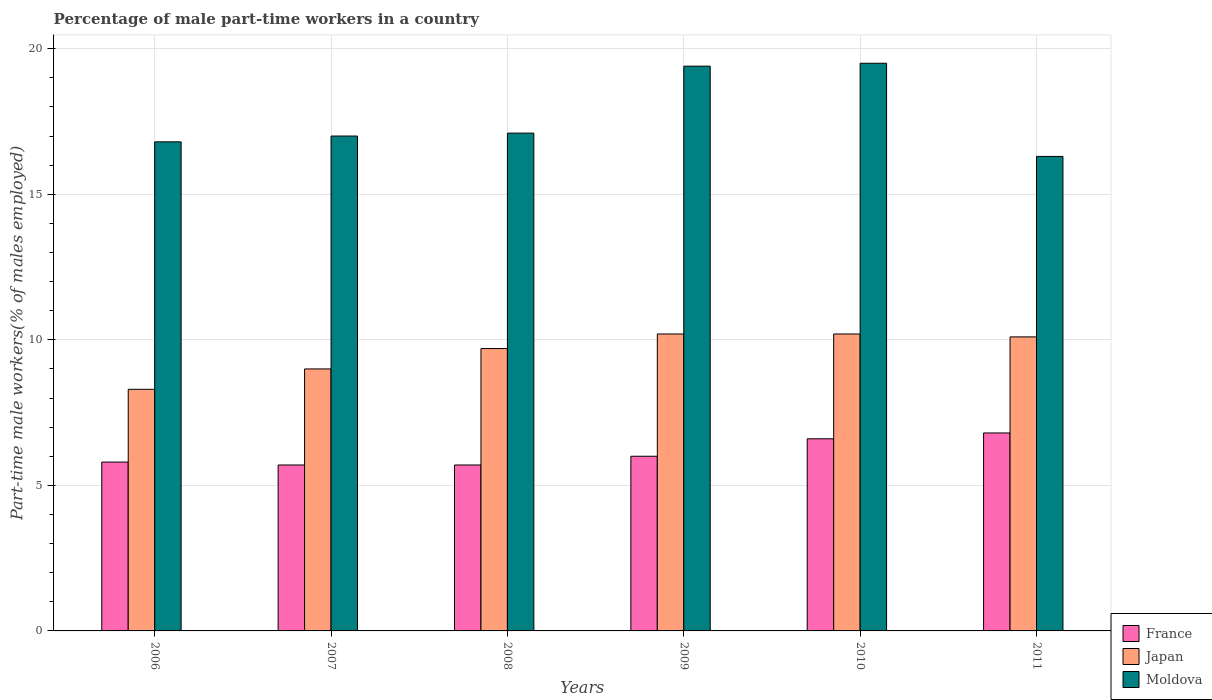How many groups of bars are there?
Make the answer very short. 6. Are the number of bars per tick equal to the number of legend labels?
Your answer should be very brief. Yes. How many bars are there on the 4th tick from the right?
Make the answer very short. 3. In how many cases, is the number of bars for a given year not equal to the number of legend labels?
Your response must be concise. 0. What is the percentage of male part-time workers in Moldova in 2007?
Your answer should be compact. 17. Across all years, what is the maximum percentage of male part-time workers in Moldova?
Your answer should be compact. 19.5. Across all years, what is the minimum percentage of male part-time workers in France?
Your answer should be compact. 5.7. What is the total percentage of male part-time workers in Japan in the graph?
Provide a succinct answer. 57.5. What is the difference between the percentage of male part-time workers in Japan in 2007 and that in 2009?
Offer a very short reply. -1.2. What is the difference between the percentage of male part-time workers in Japan in 2008 and the percentage of male part-time workers in France in 2010?
Offer a terse response. 3.1. What is the average percentage of male part-time workers in France per year?
Keep it short and to the point. 6.1. In the year 2006, what is the difference between the percentage of male part-time workers in Japan and percentage of male part-time workers in Moldova?
Ensure brevity in your answer.  -8.5. In how many years, is the percentage of male part-time workers in France greater than 14 %?
Your answer should be compact. 0. What is the ratio of the percentage of male part-time workers in France in 2008 to that in 2011?
Keep it short and to the point. 0.84. Is the percentage of male part-time workers in France in 2008 less than that in 2009?
Your answer should be compact. Yes. Is the difference between the percentage of male part-time workers in Japan in 2007 and 2009 greater than the difference between the percentage of male part-time workers in Moldova in 2007 and 2009?
Make the answer very short. Yes. What is the difference between the highest and the second highest percentage of male part-time workers in Moldova?
Your response must be concise. 0.1. What is the difference between the highest and the lowest percentage of male part-time workers in Moldova?
Your response must be concise. 3.2. What does the 3rd bar from the left in 2008 represents?
Make the answer very short. Moldova. What does the 2nd bar from the right in 2006 represents?
Your answer should be very brief. Japan. Is it the case that in every year, the sum of the percentage of male part-time workers in France and percentage of male part-time workers in Japan is greater than the percentage of male part-time workers in Moldova?
Your response must be concise. No. How many bars are there?
Make the answer very short. 18. Are the values on the major ticks of Y-axis written in scientific E-notation?
Give a very brief answer. No. Does the graph contain any zero values?
Offer a terse response. No. Does the graph contain grids?
Ensure brevity in your answer.  Yes. How many legend labels are there?
Offer a very short reply. 3. What is the title of the graph?
Your answer should be compact. Percentage of male part-time workers in a country. What is the label or title of the X-axis?
Ensure brevity in your answer.  Years. What is the label or title of the Y-axis?
Your answer should be very brief. Part-time male workers(% of males employed). What is the Part-time male workers(% of males employed) in France in 2006?
Provide a succinct answer. 5.8. What is the Part-time male workers(% of males employed) in Japan in 2006?
Give a very brief answer. 8.3. What is the Part-time male workers(% of males employed) in Moldova in 2006?
Provide a short and direct response. 16.8. What is the Part-time male workers(% of males employed) in France in 2007?
Make the answer very short. 5.7. What is the Part-time male workers(% of males employed) in Moldova in 2007?
Offer a very short reply. 17. What is the Part-time male workers(% of males employed) in France in 2008?
Offer a very short reply. 5.7. What is the Part-time male workers(% of males employed) in Japan in 2008?
Your response must be concise. 9.7. What is the Part-time male workers(% of males employed) of Moldova in 2008?
Give a very brief answer. 17.1. What is the Part-time male workers(% of males employed) in Japan in 2009?
Offer a very short reply. 10.2. What is the Part-time male workers(% of males employed) in Moldova in 2009?
Ensure brevity in your answer.  19.4. What is the Part-time male workers(% of males employed) in France in 2010?
Your response must be concise. 6.6. What is the Part-time male workers(% of males employed) of Japan in 2010?
Give a very brief answer. 10.2. What is the Part-time male workers(% of males employed) in France in 2011?
Keep it short and to the point. 6.8. What is the Part-time male workers(% of males employed) in Japan in 2011?
Offer a very short reply. 10.1. What is the Part-time male workers(% of males employed) in Moldova in 2011?
Your answer should be compact. 16.3. Across all years, what is the maximum Part-time male workers(% of males employed) in France?
Give a very brief answer. 6.8. Across all years, what is the maximum Part-time male workers(% of males employed) of Japan?
Your answer should be very brief. 10.2. Across all years, what is the maximum Part-time male workers(% of males employed) of Moldova?
Keep it short and to the point. 19.5. Across all years, what is the minimum Part-time male workers(% of males employed) in France?
Provide a succinct answer. 5.7. Across all years, what is the minimum Part-time male workers(% of males employed) of Japan?
Keep it short and to the point. 8.3. Across all years, what is the minimum Part-time male workers(% of males employed) of Moldova?
Provide a succinct answer. 16.3. What is the total Part-time male workers(% of males employed) of France in the graph?
Keep it short and to the point. 36.6. What is the total Part-time male workers(% of males employed) of Japan in the graph?
Keep it short and to the point. 57.5. What is the total Part-time male workers(% of males employed) of Moldova in the graph?
Give a very brief answer. 106.1. What is the difference between the Part-time male workers(% of males employed) in France in 2006 and that in 2009?
Make the answer very short. -0.2. What is the difference between the Part-time male workers(% of males employed) of Japan in 2006 and that in 2009?
Give a very brief answer. -1.9. What is the difference between the Part-time male workers(% of males employed) of France in 2006 and that in 2010?
Ensure brevity in your answer.  -0.8. What is the difference between the Part-time male workers(% of males employed) in Moldova in 2006 and that in 2010?
Give a very brief answer. -2.7. What is the difference between the Part-time male workers(% of males employed) of Japan in 2007 and that in 2008?
Offer a terse response. -0.7. What is the difference between the Part-time male workers(% of males employed) of Japan in 2007 and that in 2009?
Your answer should be compact. -1.2. What is the difference between the Part-time male workers(% of males employed) in Japan in 2007 and that in 2010?
Your answer should be very brief. -1.2. What is the difference between the Part-time male workers(% of males employed) in France in 2007 and that in 2011?
Make the answer very short. -1.1. What is the difference between the Part-time male workers(% of males employed) in Moldova in 2007 and that in 2011?
Offer a very short reply. 0.7. What is the difference between the Part-time male workers(% of males employed) in Japan in 2008 and that in 2009?
Provide a short and direct response. -0.5. What is the difference between the Part-time male workers(% of males employed) of France in 2008 and that in 2011?
Your response must be concise. -1.1. What is the difference between the Part-time male workers(% of males employed) of Japan in 2008 and that in 2011?
Ensure brevity in your answer.  -0.4. What is the difference between the Part-time male workers(% of males employed) of France in 2009 and that in 2010?
Ensure brevity in your answer.  -0.6. What is the difference between the Part-time male workers(% of males employed) in Moldova in 2009 and that in 2010?
Provide a short and direct response. -0.1. What is the difference between the Part-time male workers(% of males employed) in Japan in 2009 and that in 2011?
Your response must be concise. 0.1. What is the difference between the Part-time male workers(% of males employed) in Moldova in 2009 and that in 2011?
Provide a succinct answer. 3.1. What is the difference between the Part-time male workers(% of males employed) in France in 2010 and that in 2011?
Provide a succinct answer. -0.2. What is the difference between the Part-time male workers(% of males employed) of Moldova in 2010 and that in 2011?
Your response must be concise. 3.2. What is the difference between the Part-time male workers(% of males employed) in Japan in 2006 and the Part-time male workers(% of males employed) in Moldova in 2007?
Provide a succinct answer. -8.7. What is the difference between the Part-time male workers(% of males employed) of France in 2006 and the Part-time male workers(% of males employed) of Japan in 2009?
Make the answer very short. -4.4. What is the difference between the Part-time male workers(% of males employed) of Japan in 2006 and the Part-time male workers(% of males employed) of Moldova in 2009?
Ensure brevity in your answer.  -11.1. What is the difference between the Part-time male workers(% of males employed) in France in 2006 and the Part-time male workers(% of males employed) in Japan in 2010?
Your answer should be compact. -4.4. What is the difference between the Part-time male workers(% of males employed) of France in 2006 and the Part-time male workers(% of males employed) of Moldova in 2010?
Your answer should be very brief. -13.7. What is the difference between the Part-time male workers(% of males employed) in Japan in 2006 and the Part-time male workers(% of males employed) in Moldova in 2010?
Keep it short and to the point. -11.2. What is the difference between the Part-time male workers(% of males employed) in France in 2006 and the Part-time male workers(% of males employed) in Japan in 2011?
Provide a short and direct response. -4.3. What is the difference between the Part-time male workers(% of males employed) of France in 2006 and the Part-time male workers(% of males employed) of Moldova in 2011?
Give a very brief answer. -10.5. What is the difference between the Part-time male workers(% of males employed) in Japan in 2006 and the Part-time male workers(% of males employed) in Moldova in 2011?
Offer a terse response. -8. What is the difference between the Part-time male workers(% of males employed) in France in 2007 and the Part-time male workers(% of males employed) in Japan in 2008?
Provide a succinct answer. -4. What is the difference between the Part-time male workers(% of males employed) of France in 2007 and the Part-time male workers(% of males employed) of Moldova in 2008?
Offer a terse response. -11.4. What is the difference between the Part-time male workers(% of males employed) in France in 2007 and the Part-time male workers(% of males employed) in Moldova in 2009?
Provide a short and direct response. -13.7. What is the difference between the Part-time male workers(% of males employed) in Japan in 2007 and the Part-time male workers(% of males employed) in Moldova in 2009?
Provide a short and direct response. -10.4. What is the difference between the Part-time male workers(% of males employed) in France in 2007 and the Part-time male workers(% of males employed) in Japan in 2011?
Make the answer very short. -4.4. What is the difference between the Part-time male workers(% of males employed) in France in 2007 and the Part-time male workers(% of males employed) in Moldova in 2011?
Provide a succinct answer. -10.6. What is the difference between the Part-time male workers(% of males employed) in Japan in 2007 and the Part-time male workers(% of males employed) in Moldova in 2011?
Ensure brevity in your answer.  -7.3. What is the difference between the Part-time male workers(% of males employed) in France in 2008 and the Part-time male workers(% of males employed) in Japan in 2009?
Offer a terse response. -4.5. What is the difference between the Part-time male workers(% of males employed) of France in 2008 and the Part-time male workers(% of males employed) of Moldova in 2009?
Keep it short and to the point. -13.7. What is the difference between the Part-time male workers(% of males employed) in Japan in 2008 and the Part-time male workers(% of males employed) in Moldova in 2010?
Make the answer very short. -9.8. What is the difference between the Part-time male workers(% of males employed) in France in 2008 and the Part-time male workers(% of males employed) in Japan in 2011?
Your response must be concise. -4.4. What is the difference between the Part-time male workers(% of males employed) in Japan in 2008 and the Part-time male workers(% of males employed) in Moldova in 2011?
Keep it short and to the point. -6.6. What is the difference between the Part-time male workers(% of males employed) in France in 2009 and the Part-time male workers(% of males employed) in Japan in 2010?
Your answer should be compact. -4.2. What is the difference between the Part-time male workers(% of males employed) in France in 2009 and the Part-time male workers(% of males employed) in Moldova in 2010?
Provide a succinct answer. -13.5. What is the difference between the Part-time male workers(% of males employed) in Japan in 2009 and the Part-time male workers(% of males employed) in Moldova in 2011?
Your answer should be compact. -6.1. What is the difference between the Part-time male workers(% of males employed) of France in 2010 and the Part-time male workers(% of males employed) of Japan in 2011?
Your response must be concise. -3.5. What is the average Part-time male workers(% of males employed) of Japan per year?
Give a very brief answer. 9.58. What is the average Part-time male workers(% of males employed) in Moldova per year?
Provide a succinct answer. 17.68. In the year 2006, what is the difference between the Part-time male workers(% of males employed) of France and Part-time male workers(% of males employed) of Japan?
Keep it short and to the point. -2.5. In the year 2006, what is the difference between the Part-time male workers(% of males employed) of France and Part-time male workers(% of males employed) of Moldova?
Ensure brevity in your answer.  -11. In the year 2007, what is the difference between the Part-time male workers(% of males employed) of Japan and Part-time male workers(% of males employed) of Moldova?
Offer a very short reply. -8. In the year 2008, what is the difference between the Part-time male workers(% of males employed) of France and Part-time male workers(% of males employed) of Moldova?
Provide a succinct answer. -11.4. In the year 2008, what is the difference between the Part-time male workers(% of males employed) of Japan and Part-time male workers(% of males employed) of Moldova?
Give a very brief answer. -7.4. In the year 2009, what is the difference between the Part-time male workers(% of males employed) in France and Part-time male workers(% of males employed) in Moldova?
Your response must be concise. -13.4. In the year 2010, what is the difference between the Part-time male workers(% of males employed) in France and Part-time male workers(% of males employed) in Moldova?
Make the answer very short. -12.9. In the year 2010, what is the difference between the Part-time male workers(% of males employed) of Japan and Part-time male workers(% of males employed) of Moldova?
Ensure brevity in your answer.  -9.3. In the year 2011, what is the difference between the Part-time male workers(% of males employed) in Japan and Part-time male workers(% of males employed) in Moldova?
Keep it short and to the point. -6.2. What is the ratio of the Part-time male workers(% of males employed) of France in 2006 to that in 2007?
Give a very brief answer. 1.02. What is the ratio of the Part-time male workers(% of males employed) of Japan in 2006 to that in 2007?
Keep it short and to the point. 0.92. What is the ratio of the Part-time male workers(% of males employed) of Moldova in 2006 to that in 2007?
Make the answer very short. 0.99. What is the ratio of the Part-time male workers(% of males employed) in France in 2006 to that in 2008?
Give a very brief answer. 1.02. What is the ratio of the Part-time male workers(% of males employed) of Japan in 2006 to that in 2008?
Offer a very short reply. 0.86. What is the ratio of the Part-time male workers(% of males employed) in Moldova in 2006 to that in 2008?
Provide a short and direct response. 0.98. What is the ratio of the Part-time male workers(% of males employed) in France in 2006 to that in 2009?
Provide a short and direct response. 0.97. What is the ratio of the Part-time male workers(% of males employed) in Japan in 2006 to that in 2009?
Offer a very short reply. 0.81. What is the ratio of the Part-time male workers(% of males employed) in Moldova in 2006 to that in 2009?
Make the answer very short. 0.87. What is the ratio of the Part-time male workers(% of males employed) of France in 2006 to that in 2010?
Make the answer very short. 0.88. What is the ratio of the Part-time male workers(% of males employed) in Japan in 2006 to that in 2010?
Offer a very short reply. 0.81. What is the ratio of the Part-time male workers(% of males employed) of Moldova in 2006 to that in 2010?
Make the answer very short. 0.86. What is the ratio of the Part-time male workers(% of males employed) in France in 2006 to that in 2011?
Offer a terse response. 0.85. What is the ratio of the Part-time male workers(% of males employed) of Japan in 2006 to that in 2011?
Your answer should be very brief. 0.82. What is the ratio of the Part-time male workers(% of males employed) of Moldova in 2006 to that in 2011?
Your answer should be compact. 1.03. What is the ratio of the Part-time male workers(% of males employed) in Japan in 2007 to that in 2008?
Ensure brevity in your answer.  0.93. What is the ratio of the Part-time male workers(% of males employed) of Japan in 2007 to that in 2009?
Your response must be concise. 0.88. What is the ratio of the Part-time male workers(% of males employed) in Moldova in 2007 to that in 2009?
Offer a terse response. 0.88. What is the ratio of the Part-time male workers(% of males employed) in France in 2007 to that in 2010?
Provide a succinct answer. 0.86. What is the ratio of the Part-time male workers(% of males employed) of Japan in 2007 to that in 2010?
Ensure brevity in your answer.  0.88. What is the ratio of the Part-time male workers(% of males employed) in Moldova in 2007 to that in 2010?
Provide a short and direct response. 0.87. What is the ratio of the Part-time male workers(% of males employed) in France in 2007 to that in 2011?
Keep it short and to the point. 0.84. What is the ratio of the Part-time male workers(% of males employed) in Japan in 2007 to that in 2011?
Give a very brief answer. 0.89. What is the ratio of the Part-time male workers(% of males employed) of Moldova in 2007 to that in 2011?
Offer a very short reply. 1.04. What is the ratio of the Part-time male workers(% of males employed) of Japan in 2008 to that in 2009?
Offer a terse response. 0.95. What is the ratio of the Part-time male workers(% of males employed) of Moldova in 2008 to that in 2009?
Offer a very short reply. 0.88. What is the ratio of the Part-time male workers(% of males employed) in France in 2008 to that in 2010?
Provide a short and direct response. 0.86. What is the ratio of the Part-time male workers(% of males employed) of Japan in 2008 to that in 2010?
Offer a terse response. 0.95. What is the ratio of the Part-time male workers(% of males employed) in Moldova in 2008 to that in 2010?
Your answer should be compact. 0.88. What is the ratio of the Part-time male workers(% of males employed) in France in 2008 to that in 2011?
Provide a short and direct response. 0.84. What is the ratio of the Part-time male workers(% of males employed) in Japan in 2008 to that in 2011?
Ensure brevity in your answer.  0.96. What is the ratio of the Part-time male workers(% of males employed) of Moldova in 2008 to that in 2011?
Provide a succinct answer. 1.05. What is the ratio of the Part-time male workers(% of males employed) of Moldova in 2009 to that in 2010?
Offer a terse response. 0.99. What is the ratio of the Part-time male workers(% of males employed) of France in 2009 to that in 2011?
Ensure brevity in your answer.  0.88. What is the ratio of the Part-time male workers(% of males employed) in Japan in 2009 to that in 2011?
Make the answer very short. 1.01. What is the ratio of the Part-time male workers(% of males employed) in Moldova in 2009 to that in 2011?
Keep it short and to the point. 1.19. What is the ratio of the Part-time male workers(% of males employed) in France in 2010 to that in 2011?
Offer a terse response. 0.97. What is the ratio of the Part-time male workers(% of males employed) in Japan in 2010 to that in 2011?
Your answer should be very brief. 1.01. What is the ratio of the Part-time male workers(% of males employed) in Moldova in 2010 to that in 2011?
Give a very brief answer. 1.2. What is the difference between the highest and the second highest Part-time male workers(% of males employed) of Japan?
Offer a terse response. 0. What is the difference between the highest and the second highest Part-time male workers(% of males employed) in Moldova?
Offer a terse response. 0.1. What is the difference between the highest and the lowest Part-time male workers(% of males employed) in France?
Ensure brevity in your answer.  1.1. What is the difference between the highest and the lowest Part-time male workers(% of males employed) of Japan?
Your response must be concise. 1.9. 